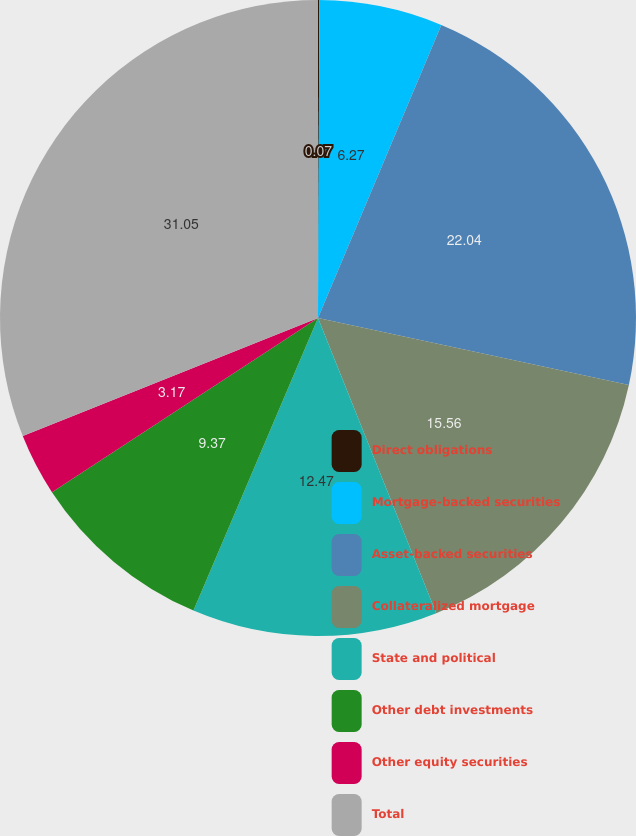Convert chart. <chart><loc_0><loc_0><loc_500><loc_500><pie_chart><fcel>Direct obligations<fcel>Mortgage-backed securities<fcel>Asset-backed securities<fcel>Collateralized mortgage<fcel>State and political<fcel>Other debt investments<fcel>Other equity securities<fcel>Total<nl><fcel>0.07%<fcel>6.27%<fcel>22.04%<fcel>15.56%<fcel>12.47%<fcel>9.37%<fcel>3.17%<fcel>31.06%<nl></chart> 